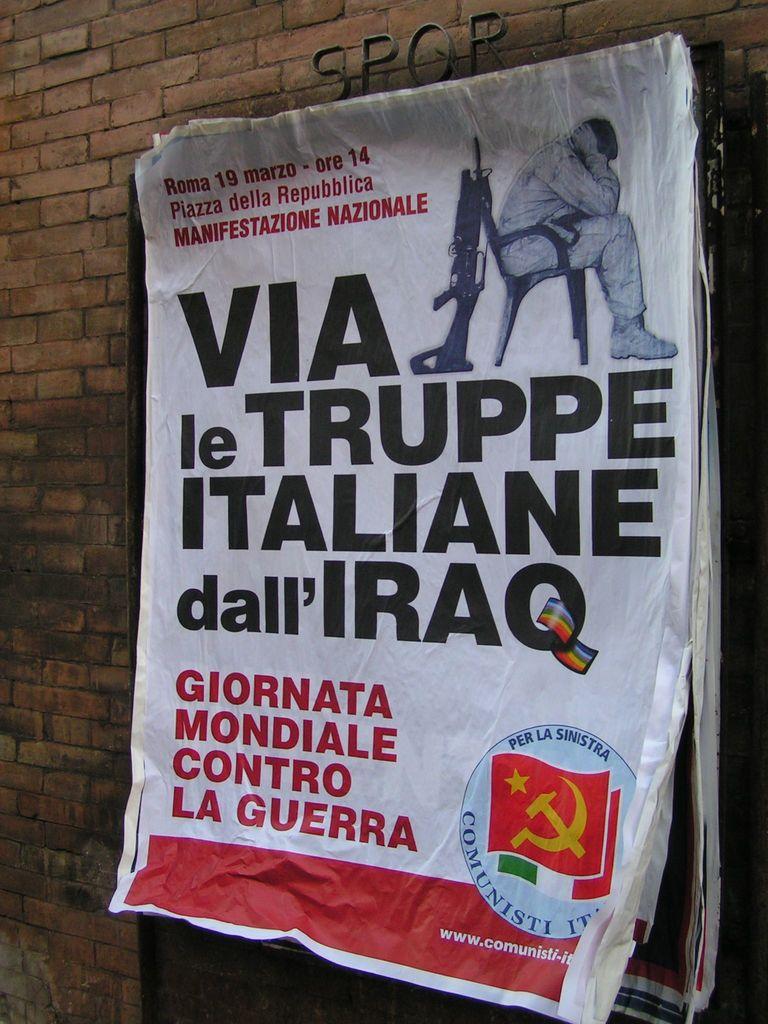Via le what?
Provide a short and direct response. Truppe. What is the numbers listed at the top?
Your answer should be very brief. 19 14. 